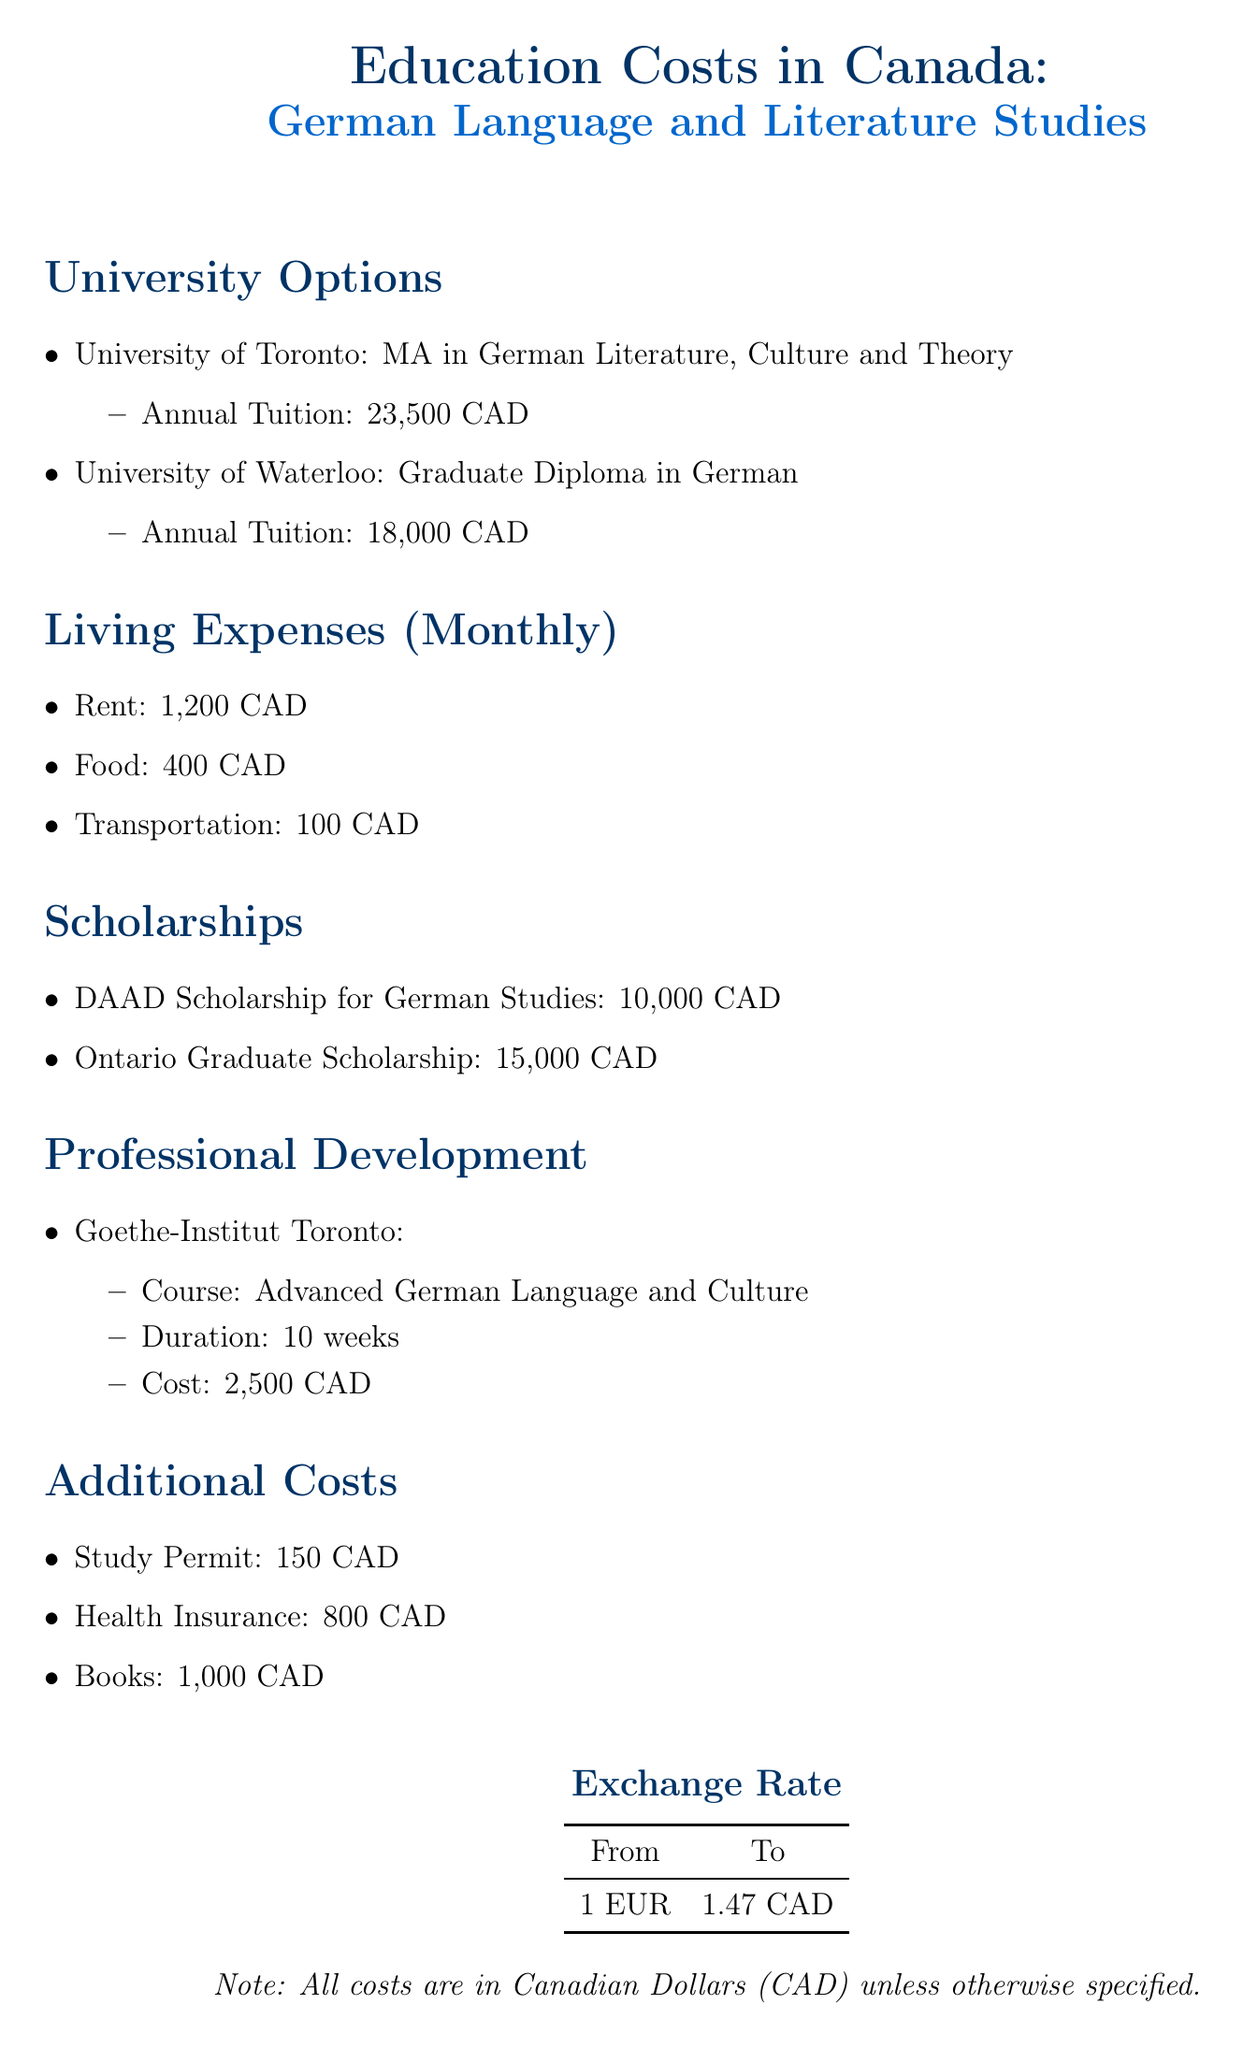What is the tuition cost for the MA in German Literature at the University of Toronto? The tuition cost is listed under the University of Toronto's program, which states it is 23,500 CAD annually.
Answer: 23,500 CAD What is the annual tuition for the Graduate Diploma in German at the University of Waterloo? The document specifies the annual tuition for the Graduate Diploma in German program at the University of Waterloo as 18,000 CAD.
Answer: 18,000 CAD What is the total monthly living expense for rent, food, and transportation? By adding the monthly rent, food, and transportation costs, which are 1,200 CAD, 400 CAD, and 100 CAD respectively, the total is calculated as 1,700 CAD.
Answer: 1,700 CAD How much is the DAAD Scholarship for German Studies? This scholarship amount is provided in the scholarships section of the document, stating it is 10,000 CAD.
Answer: 10,000 CAD What is the cost of the Advanced German Language and Culture course at Goethe-Institut Toronto? The document lists the cost of the course as 2,500 CAD under the professional development section.
Answer: 2,500 CAD What are the total additional costs listed in the document? The additional costs include the study permit, health insurance, and books, totaling to 150 CAD + 800 CAD + 1,000 CAD = 1,950 CAD.
Answer: 1,950 CAD What is the exchange rate from EUR to CAD? The exchange rate is provided in the document and is specified as 1 EUR equals 1.47 CAD.
Answer: 1.47 CAD What is the total amount available from Ontario Graduate Scholarship? This amount is listed in the scholarships section, specifically as 15,000 CAD.
Answer: 15,000 CAD 